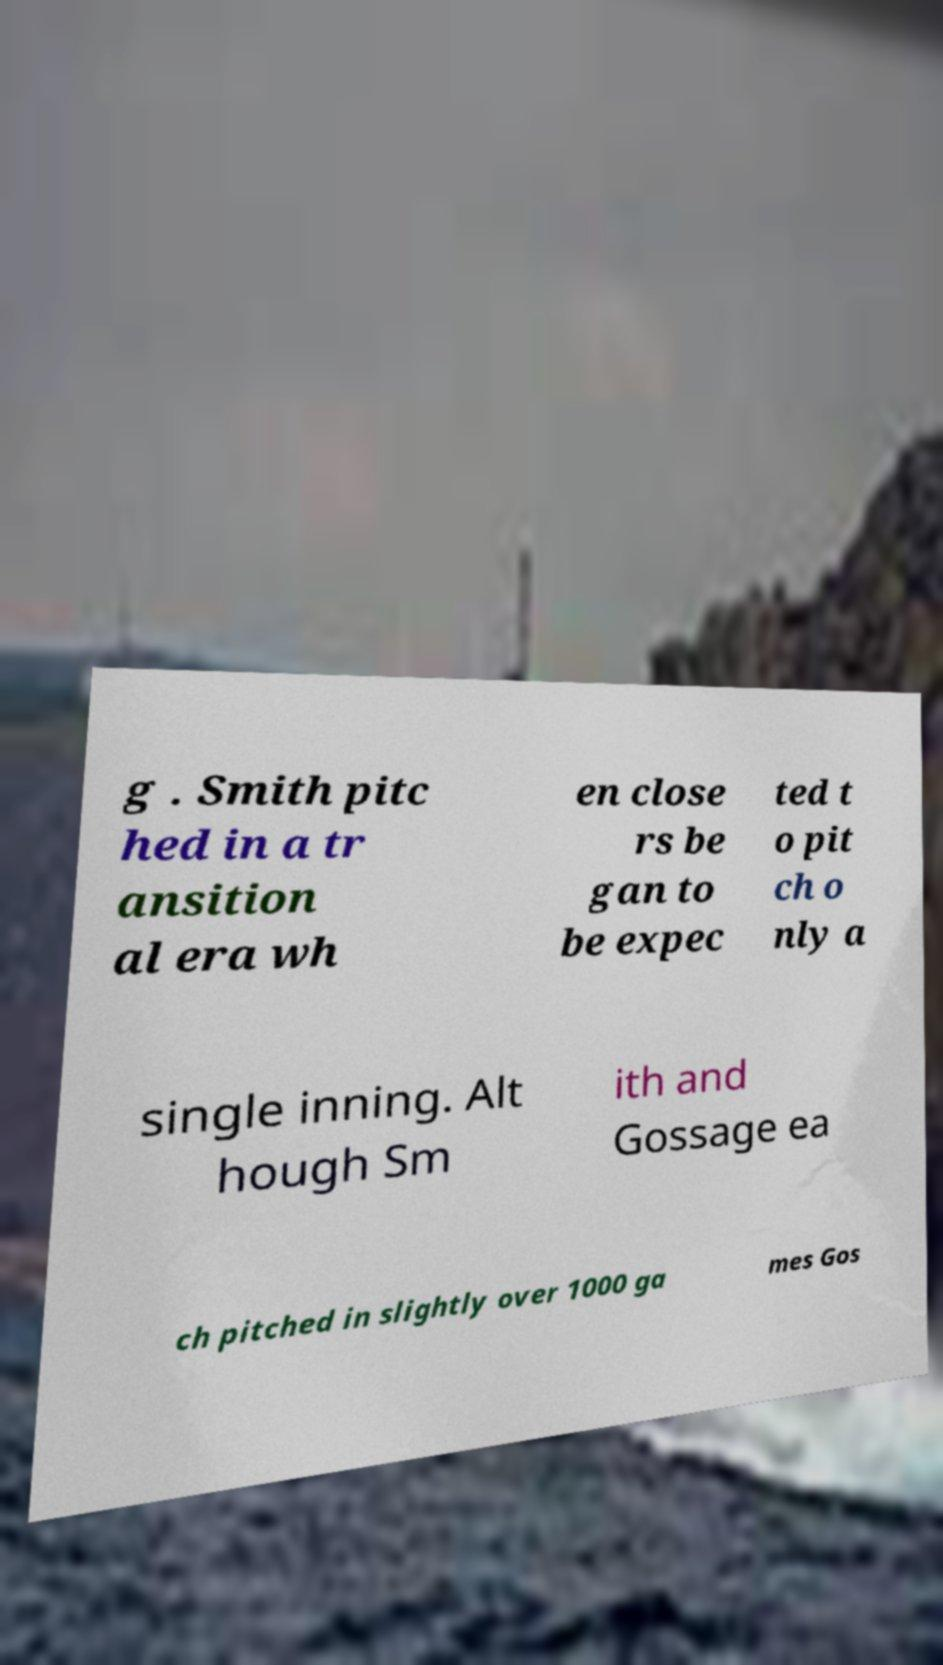Could you extract and type out the text from this image? g . Smith pitc hed in a tr ansition al era wh en close rs be gan to be expec ted t o pit ch o nly a single inning. Alt hough Sm ith and Gossage ea ch pitched in slightly over 1000 ga mes Gos 